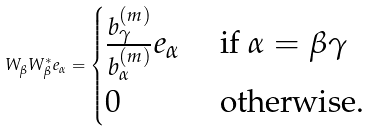<formula> <loc_0><loc_0><loc_500><loc_500>W _ { \beta } W _ { \beta } ^ { * } e _ { \alpha } = \begin{cases} \frac { { b _ { \gamma } ^ { ( m ) } } } { { b _ { \alpha } ^ { ( m ) } } } e _ { \alpha } & \text { if } \alpha = \beta \gamma \\ 0 & \text { otherwise. } \end{cases}</formula> 